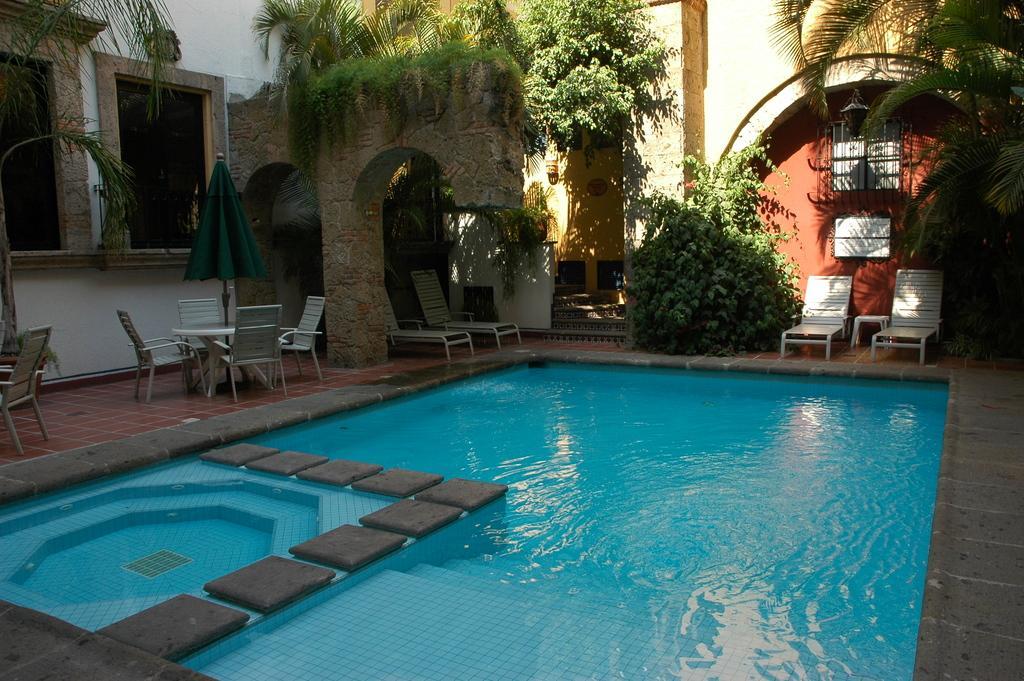Could you give a brief overview of what you see in this image? This picture is clicked outside. In the center there is a swimming pool and we can see the chairs, tables, umbrella, beach chairs, plants, trees and we can see the windows and walls of the building. 